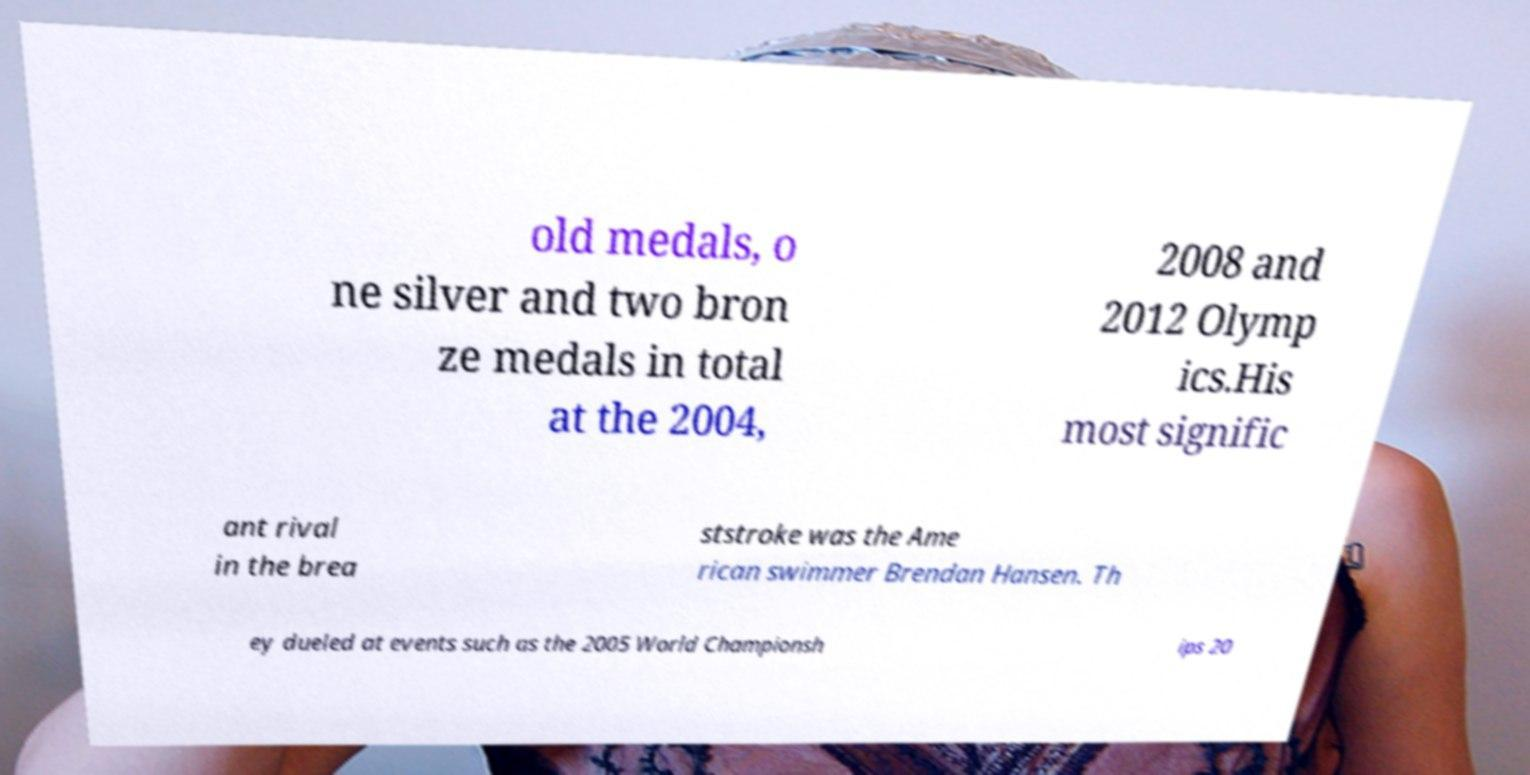What messages or text are displayed in this image? I need them in a readable, typed format. old medals, o ne silver and two bron ze medals in total at the 2004, 2008 and 2012 Olymp ics.His most signific ant rival in the brea ststroke was the Ame rican swimmer Brendan Hansen. Th ey dueled at events such as the 2005 World Championsh ips 20 